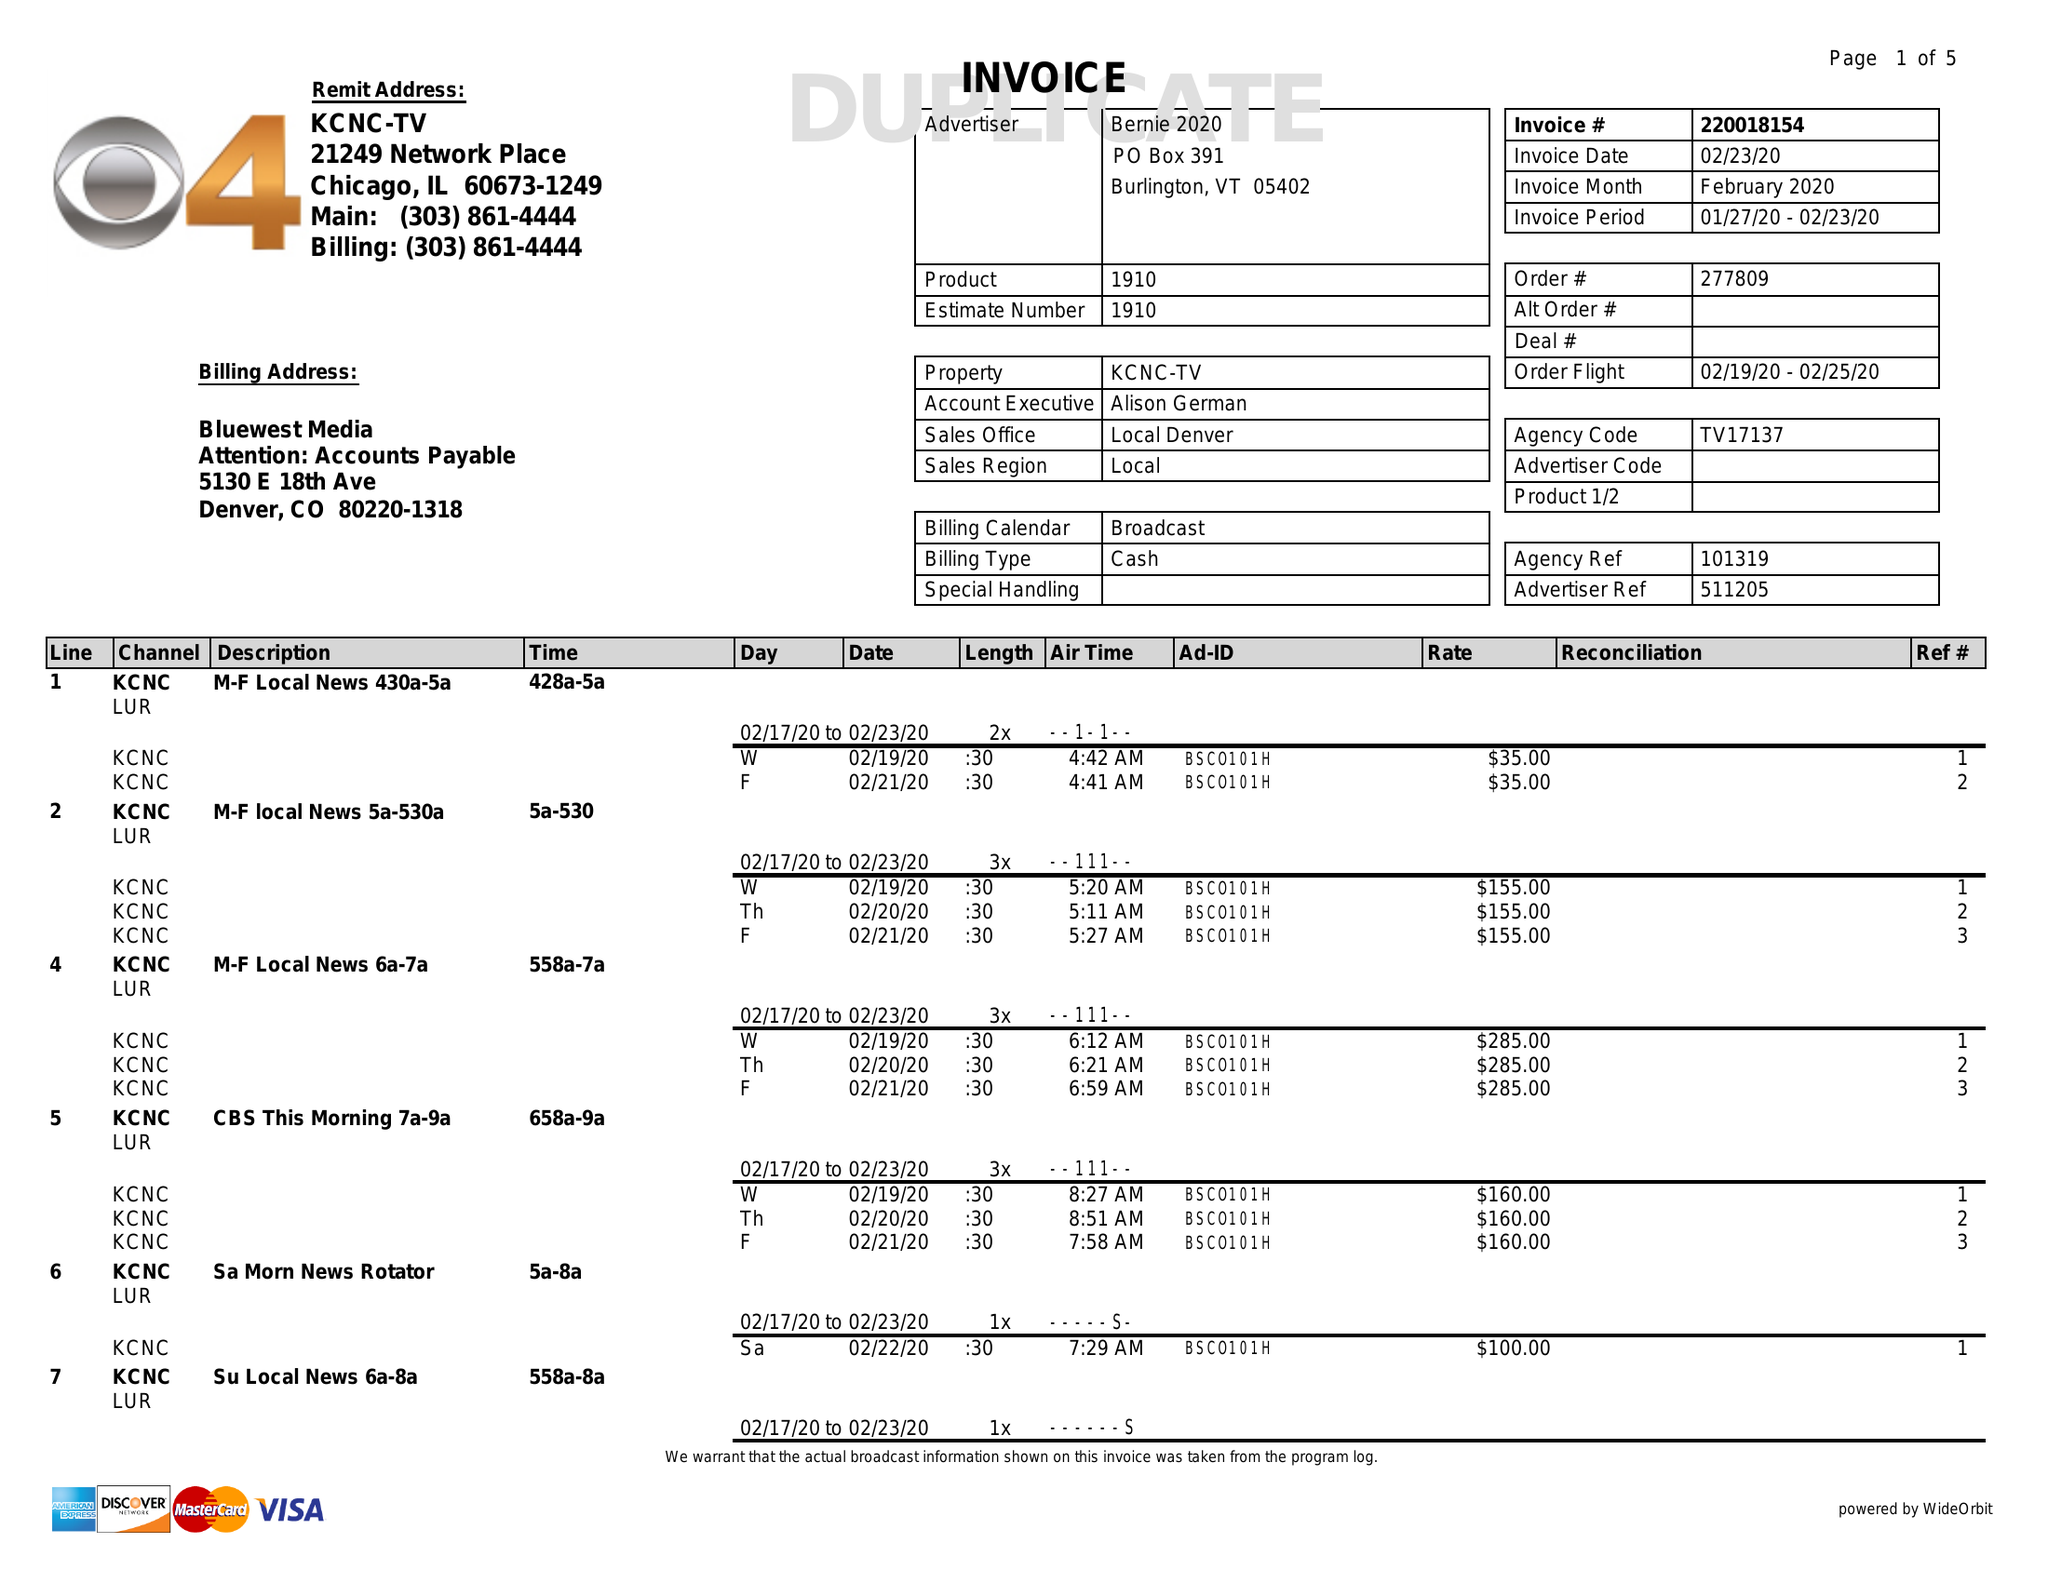What is the value for the advertiser?
Answer the question using a single word or phrase. BERNIE 2020 